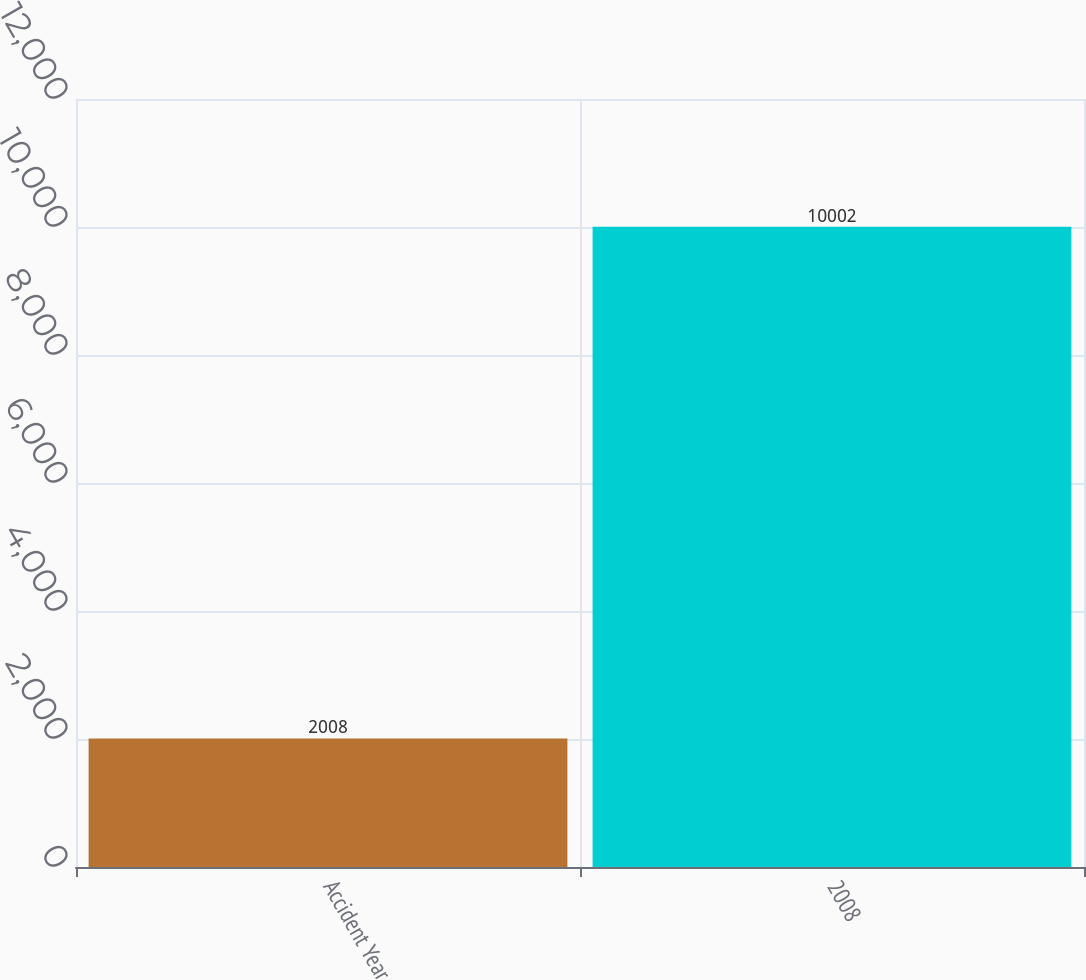<chart> <loc_0><loc_0><loc_500><loc_500><bar_chart><fcel>Accident Year<fcel>2008<nl><fcel>2008<fcel>10002<nl></chart> 